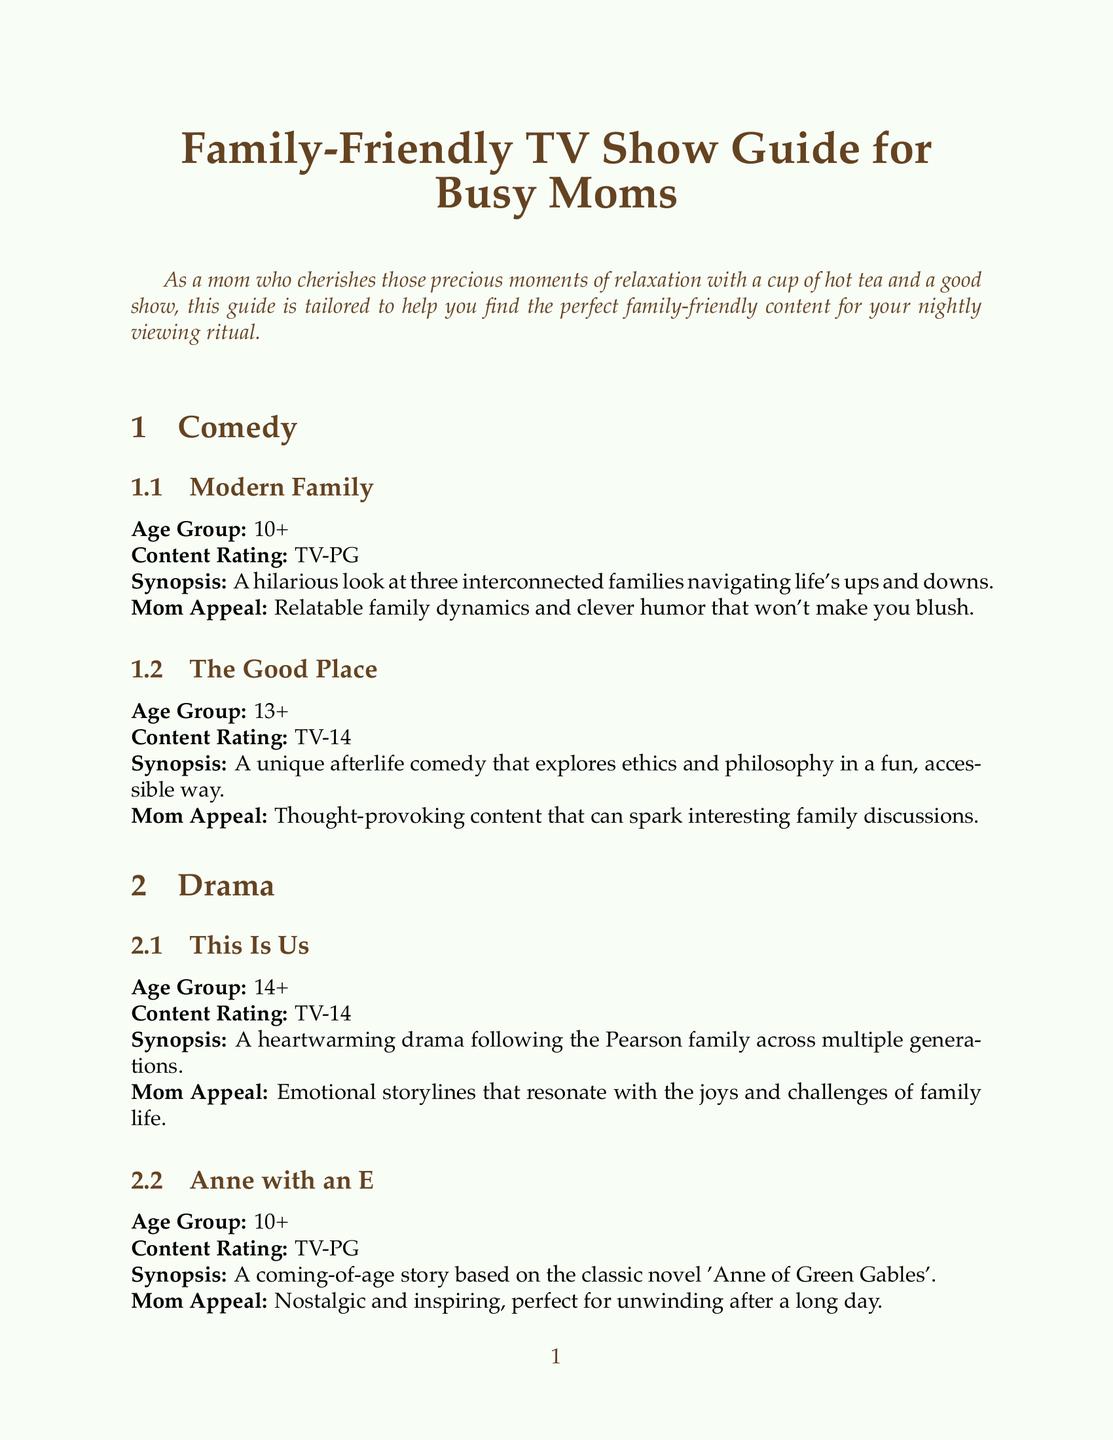What is the title of the guide? The title is clearly stated in the document, allowing for easy retrieval of the guide's name.
Answer: Family-Friendly TV Show Guide for Busy Moms What age group is "Modern Family" suitable for? The age group listed next to "Modern Family" provides specific viewing recommendations.
Answer: 10+ What is the content rating for "The Good Place"? The content rating for shows is provided in the synopsis section, clearly indicating appropriateness.
Answer: TV-14 How many shows are listed under the Educational genre? By counting the entries under the Educational section, we can determine the number of shows.
Answer: 2 What is the mom appeal of "Anne with an E"? The specific appeal for moms is listed under each show, expressing the emotional connection and benefits.
Answer: Nostalgic and inspiring, perfect for unwinding after a long day Which genre includes the show "Avatar: The Last Airbender"? Identifying the genre in which "Avatar: The Last Airbender" is categorized helps in finding similar content.
Answer: Animated What content rating does "Our Planet" have? This information is presented alongside the synopsis and age group for clarity.
Answer: TV-PG How many tips are provided for family viewing? The tips section consists of a bulleted list, making it easy to count the suggestions given.
Answer: 5 What is the primary color theme of the document? The document's design elements suggest a comforting theme, enhancing the reading experience.
Answer: Teagreen 